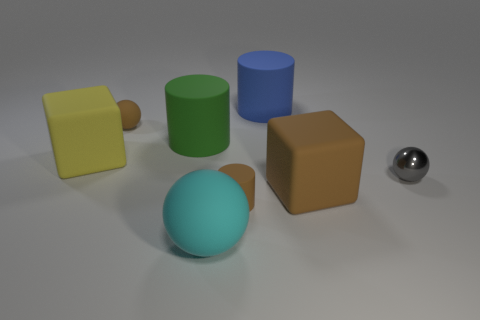Add 1 big cyan metal things. How many objects exist? 9 Subtract all spheres. How many objects are left? 5 Subtract all green rubber cylinders. Subtract all small yellow shiny things. How many objects are left? 7 Add 4 small cylinders. How many small cylinders are left? 5 Add 7 big green objects. How many big green objects exist? 8 Subtract 1 green cylinders. How many objects are left? 7 